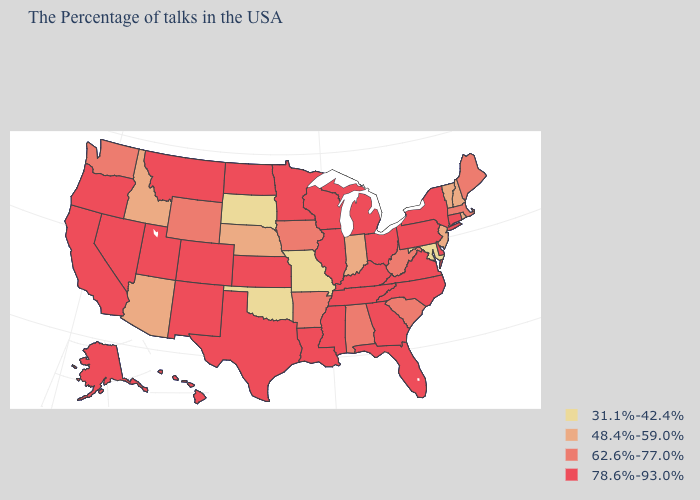Name the states that have a value in the range 78.6%-93.0%?
Give a very brief answer. Connecticut, New York, Delaware, Pennsylvania, Virginia, North Carolina, Ohio, Florida, Georgia, Michigan, Kentucky, Tennessee, Wisconsin, Illinois, Mississippi, Louisiana, Minnesota, Kansas, Texas, North Dakota, Colorado, New Mexico, Utah, Montana, Nevada, California, Oregon, Alaska, Hawaii. Name the states that have a value in the range 48.4%-59.0%?
Be succinct. Rhode Island, New Hampshire, Vermont, New Jersey, Indiana, Nebraska, Arizona, Idaho. What is the value of Montana?
Concise answer only. 78.6%-93.0%. Name the states that have a value in the range 62.6%-77.0%?
Write a very short answer. Maine, Massachusetts, South Carolina, West Virginia, Alabama, Arkansas, Iowa, Wyoming, Washington. What is the highest value in the USA?
Keep it brief. 78.6%-93.0%. What is the value of Maine?
Short answer required. 62.6%-77.0%. Which states have the highest value in the USA?
Quick response, please. Connecticut, New York, Delaware, Pennsylvania, Virginia, North Carolina, Ohio, Florida, Georgia, Michigan, Kentucky, Tennessee, Wisconsin, Illinois, Mississippi, Louisiana, Minnesota, Kansas, Texas, North Dakota, Colorado, New Mexico, Utah, Montana, Nevada, California, Oregon, Alaska, Hawaii. What is the highest value in states that border Kansas?
Answer briefly. 78.6%-93.0%. How many symbols are there in the legend?
Answer briefly. 4. Name the states that have a value in the range 31.1%-42.4%?
Keep it brief. Maryland, Missouri, Oklahoma, South Dakota. Does Illinois have a lower value than Montana?
Answer briefly. No. What is the lowest value in the Northeast?
Write a very short answer. 48.4%-59.0%. How many symbols are there in the legend?
Quick response, please. 4. Which states have the lowest value in the USA?
Concise answer only. Maryland, Missouri, Oklahoma, South Dakota. Name the states that have a value in the range 62.6%-77.0%?
Answer briefly. Maine, Massachusetts, South Carolina, West Virginia, Alabama, Arkansas, Iowa, Wyoming, Washington. 